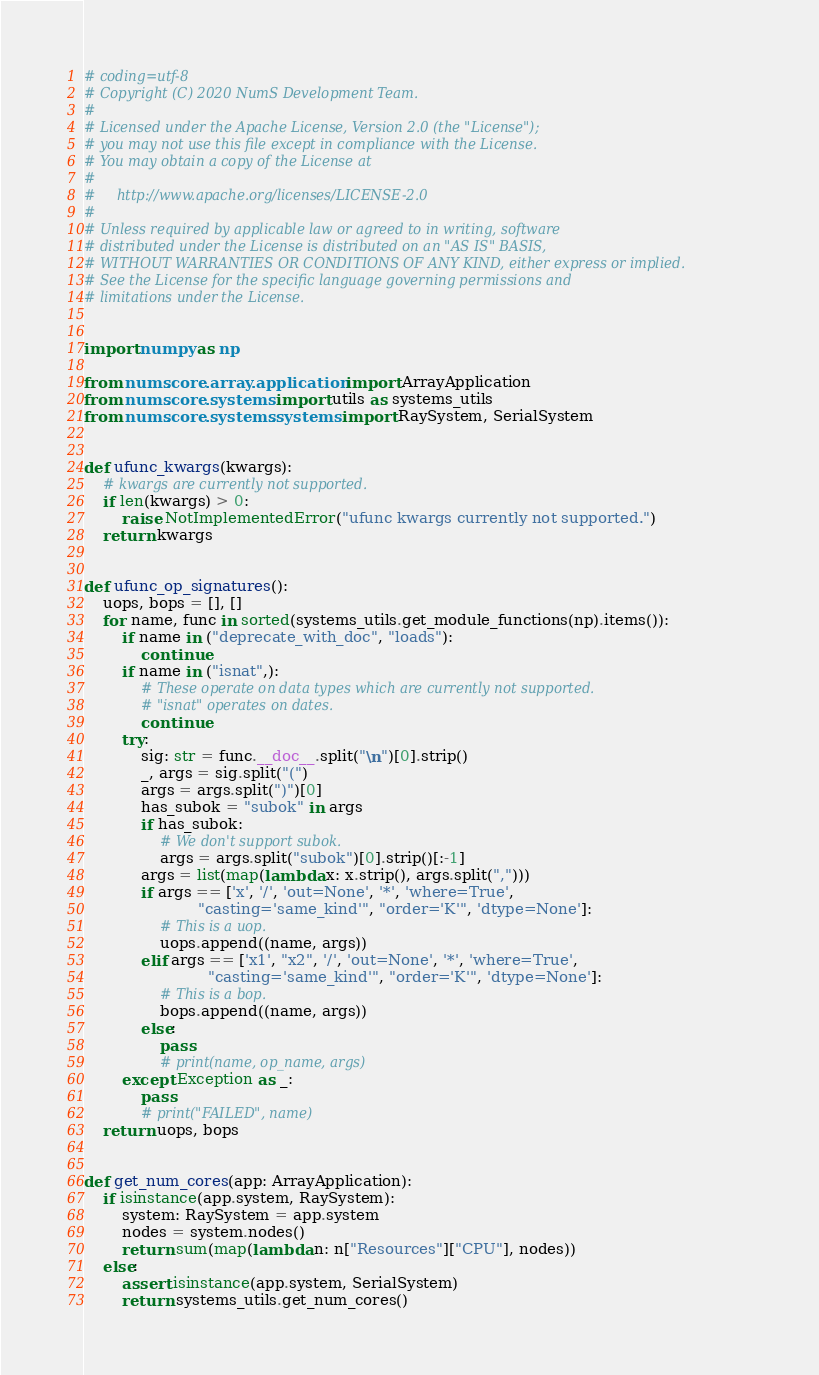Convert code to text. <code><loc_0><loc_0><loc_500><loc_500><_Python_># coding=utf-8
# Copyright (C) 2020 NumS Development Team.
#
# Licensed under the Apache License, Version 2.0 (the "License");
# you may not use this file except in compliance with the License.
# You may obtain a copy of the License at
#
#     http://www.apache.org/licenses/LICENSE-2.0
#
# Unless required by applicable law or agreed to in writing, software
# distributed under the License is distributed on an "AS IS" BASIS,
# WITHOUT WARRANTIES OR CONDITIONS OF ANY KIND, either express or implied.
# See the License for the specific language governing permissions and
# limitations under the License.


import numpy as np

from nums.core.array.application import ArrayApplication
from nums.core.systems import utils as systems_utils
from nums.core.systems.systems import RaySystem, SerialSystem


def ufunc_kwargs(kwargs):
    # kwargs are currently not supported.
    if len(kwargs) > 0:
        raise NotImplementedError("ufunc kwargs currently not supported.")
    return kwargs


def ufunc_op_signatures():
    uops, bops = [], []
    for name, func in sorted(systems_utils.get_module_functions(np).items()):
        if name in ("deprecate_with_doc", "loads"):
            continue
        if name in ("isnat",):
            # These operate on data types which are currently not supported.
            # "isnat" operates on dates.
            continue
        try:
            sig: str = func.__doc__.split("\n")[0].strip()
            _, args = sig.split("(")
            args = args.split(")")[0]
            has_subok = "subok" in args
            if has_subok:
                # We don't support subok.
                args = args.split("subok")[0].strip()[:-1]
            args = list(map(lambda x: x.strip(), args.split(",")))
            if args == ['x', '/', 'out=None', '*', 'where=True',
                        "casting='same_kind'", "order='K'", 'dtype=None']:
                # This is a uop.
                uops.append((name, args))
            elif args == ['x1', "x2", '/', 'out=None', '*', 'where=True',
                          "casting='same_kind'", "order='K'", 'dtype=None']:
                # This is a bop.
                bops.append((name, args))
            else:
                pass
                # print(name, op_name, args)
        except Exception as _:
            pass
            # print("FAILED", name)
    return uops, bops


def get_num_cores(app: ArrayApplication):
    if isinstance(app.system, RaySystem):
        system: RaySystem = app.system
        nodes = system.nodes()
        return sum(map(lambda n: n["Resources"]["CPU"], nodes))
    else:
        assert isinstance(app.system, SerialSystem)
        return systems_utils.get_num_cores()
</code> 